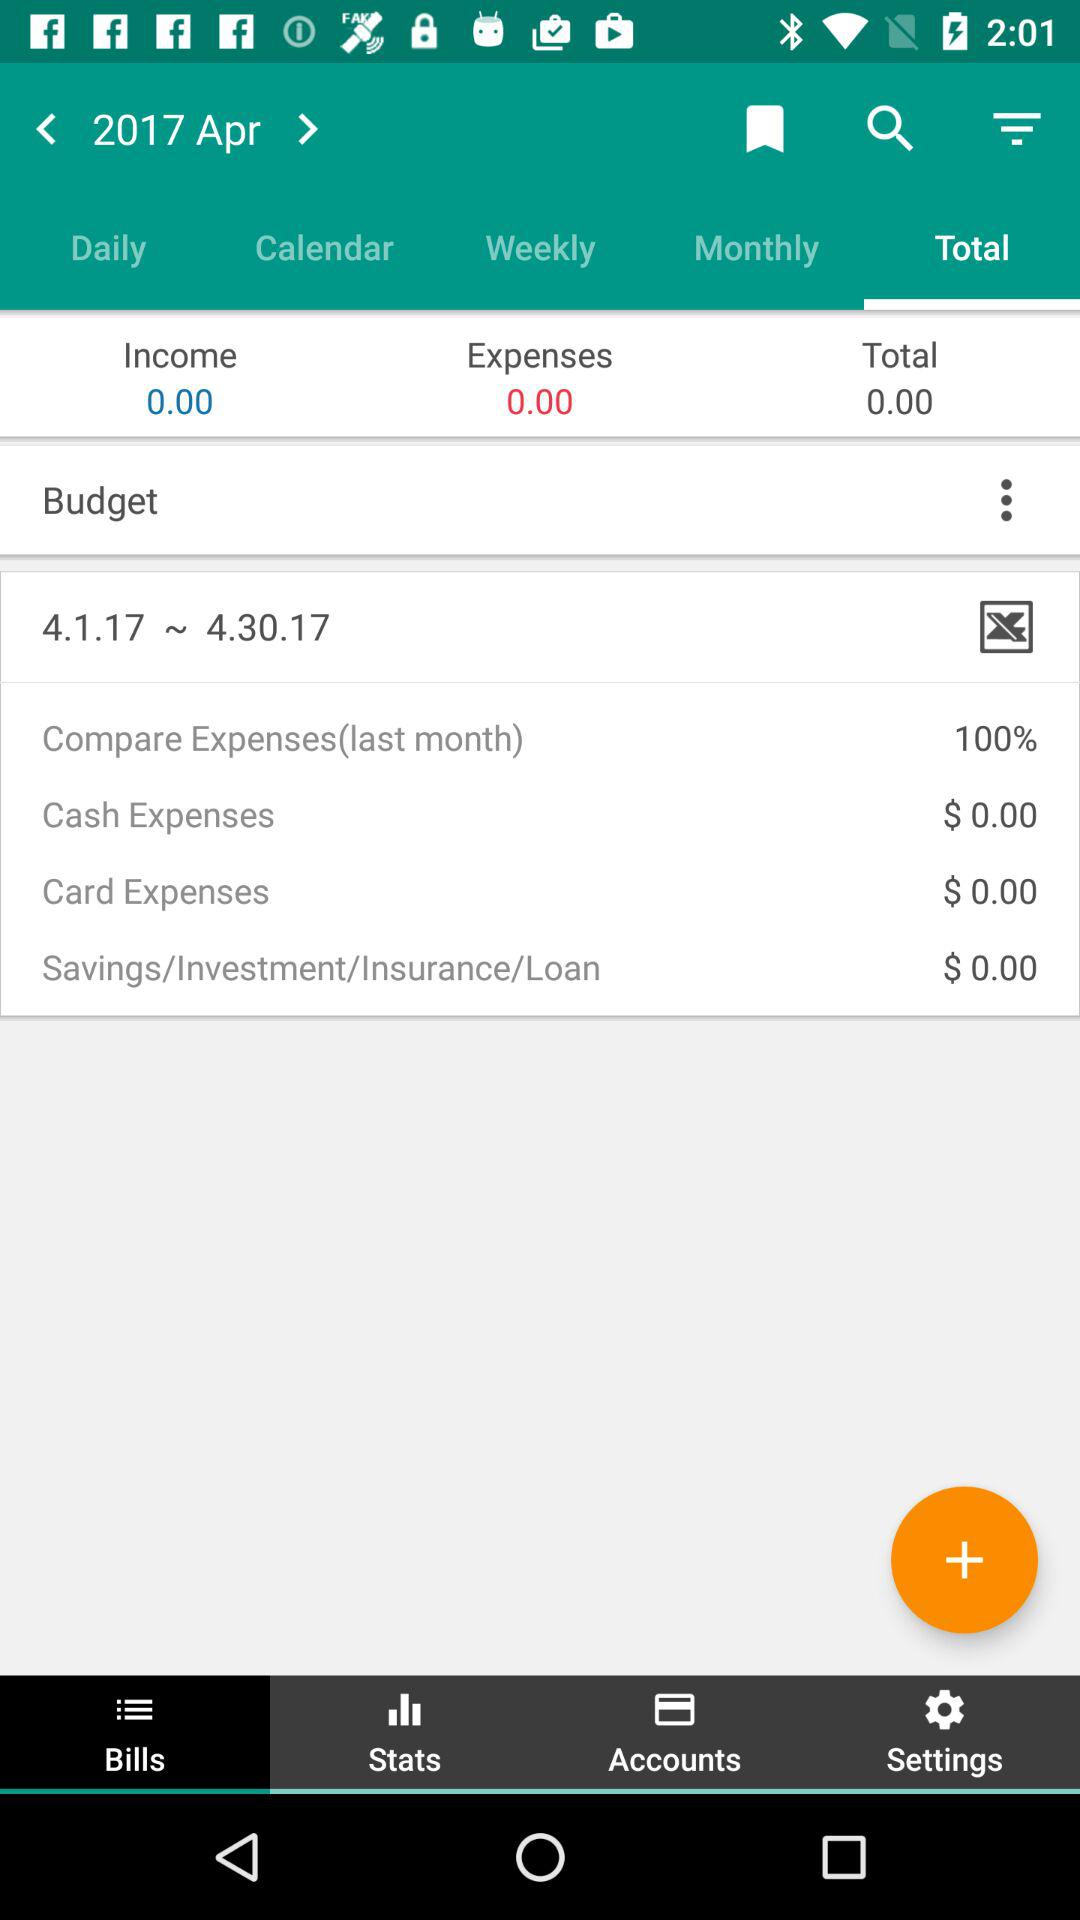How much is the income? The income is 0. 